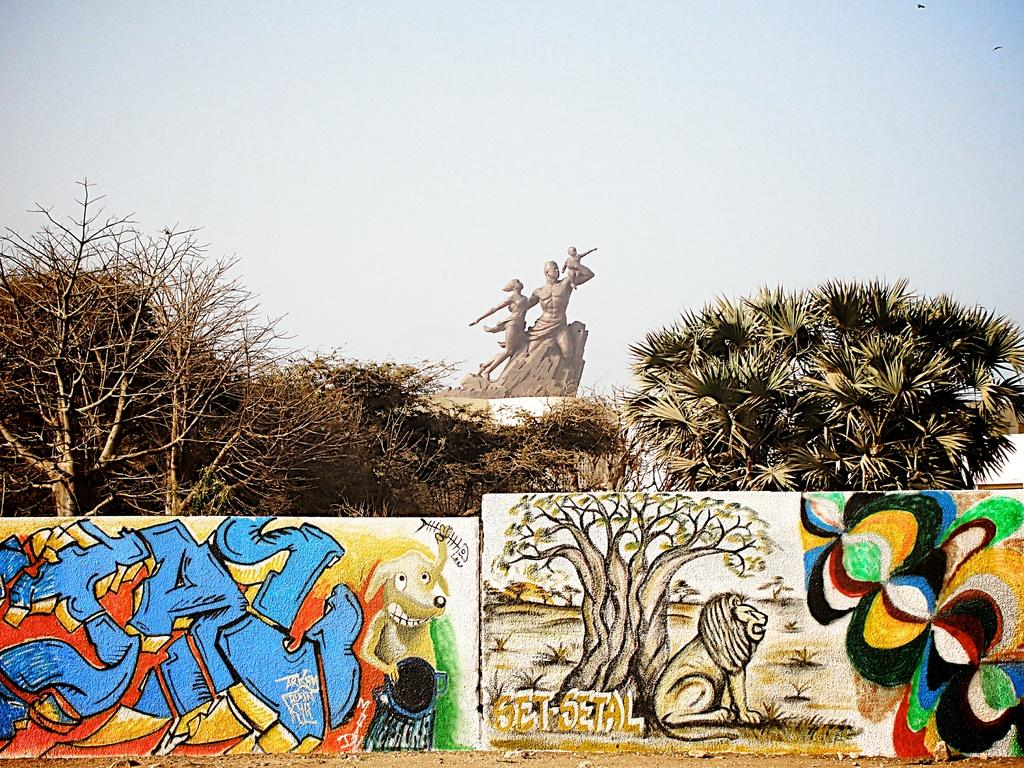What is the main subject in the image? There is a sculpture in the image. What other elements can be seen in the image? There are trees and graffiti on the walls in the image. What can be seen in the background of the image? The sky is visible in the background of the image. Are there any toys visible in the image? There are no toys present in the image. Can you see a fan in the image? There is no fan visible in the image. 